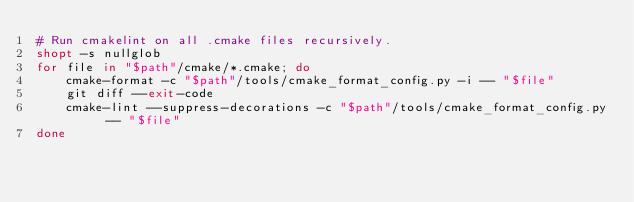Convert code to text. <code><loc_0><loc_0><loc_500><loc_500><_Bash_># Run cmakelint on all .cmake files recursively.
shopt -s nullglob
for file in "$path"/cmake/*.cmake; do
    cmake-format -c "$path"/tools/cmake_format_config.py -i -- "$file"
    git diff --exit-code
    cmake-lint --suppress-decorations -c "$path"/tools/cmake_format_config.py -- "$file"
done
</code> 